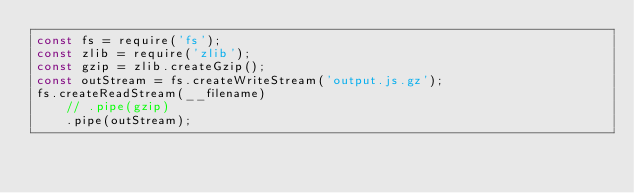Convert code to text. <code><loc_0><loc_0><loc_500><loc_500><_JavaScript_>const fs = require('fs');
const zlib = require('zlib');
const gzip = zlib.createGzip();
const outStream = fs.createWriteStream('output.js.gz');
fs.createReadStream(__filename)
    // .pipe(gzip)
    .pipe(outStream);
</code> 